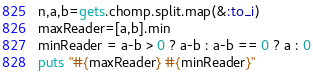<code> <loc_0><loc_0><loc_500><loc_500><_Ruby_>n,a,b=gets.chomp.split.map(&:to_i)
maxReader=[a,b].min
minReader = a-b > 0 ? a-b : a-b == 0 ? a : 0
puts "#{maxReader} #{minReader}"</code> 